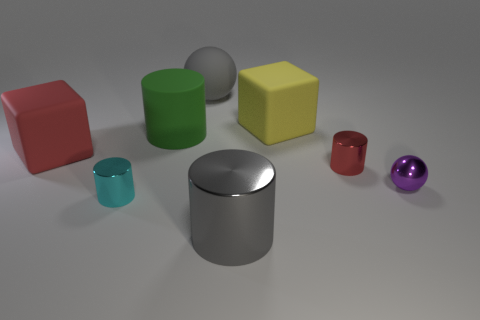Subtract all large green rubber cylinders. How many cylinders are left? 3 Subtract all yellow cubes. How many cubes are left? 1 Add 1 big cubes. How many objects exist? 9 Subtract 2 cylinders. How many cylinders are left? 2 Subtract all cubes. How many objects are left? 6 Add 7 small red shiny cylinders. How many small red shiny cylinders exist? 8 Subtract 0 cyan cubes. How many objects are left? 8 Subtract all brown blocks. Subtract all blue balls. How many blocks are left? 2 Subtract all brown cylinders. How many green blocks are left? 0 Subtract all tiny purple metal balls. Subtract all purple metallic blocks. How many objects are left? 7 